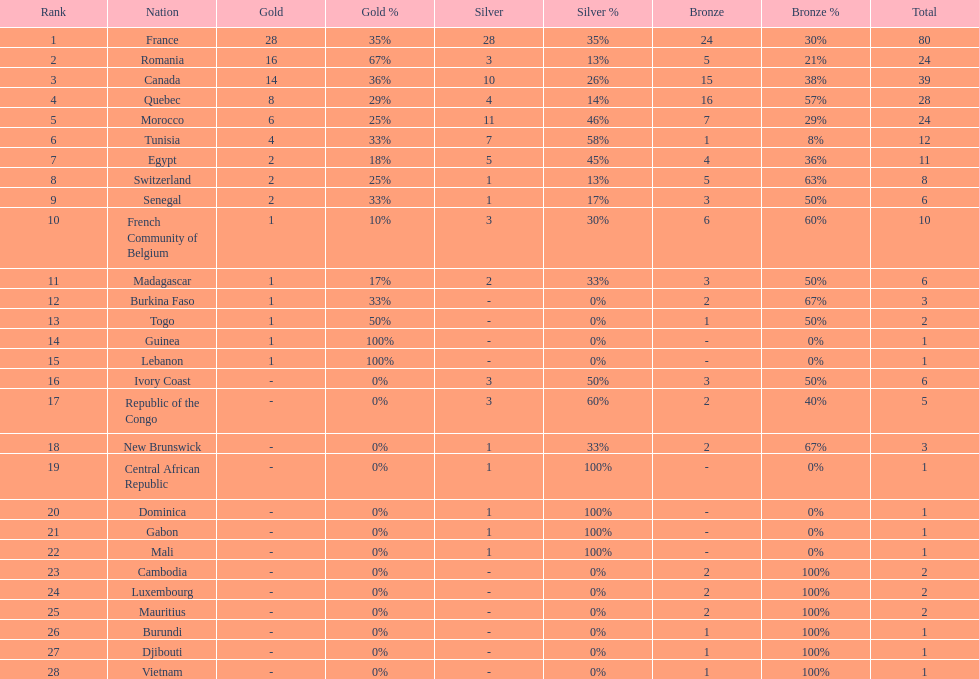What is the difference between france's and egypt's silver medals? 23. 